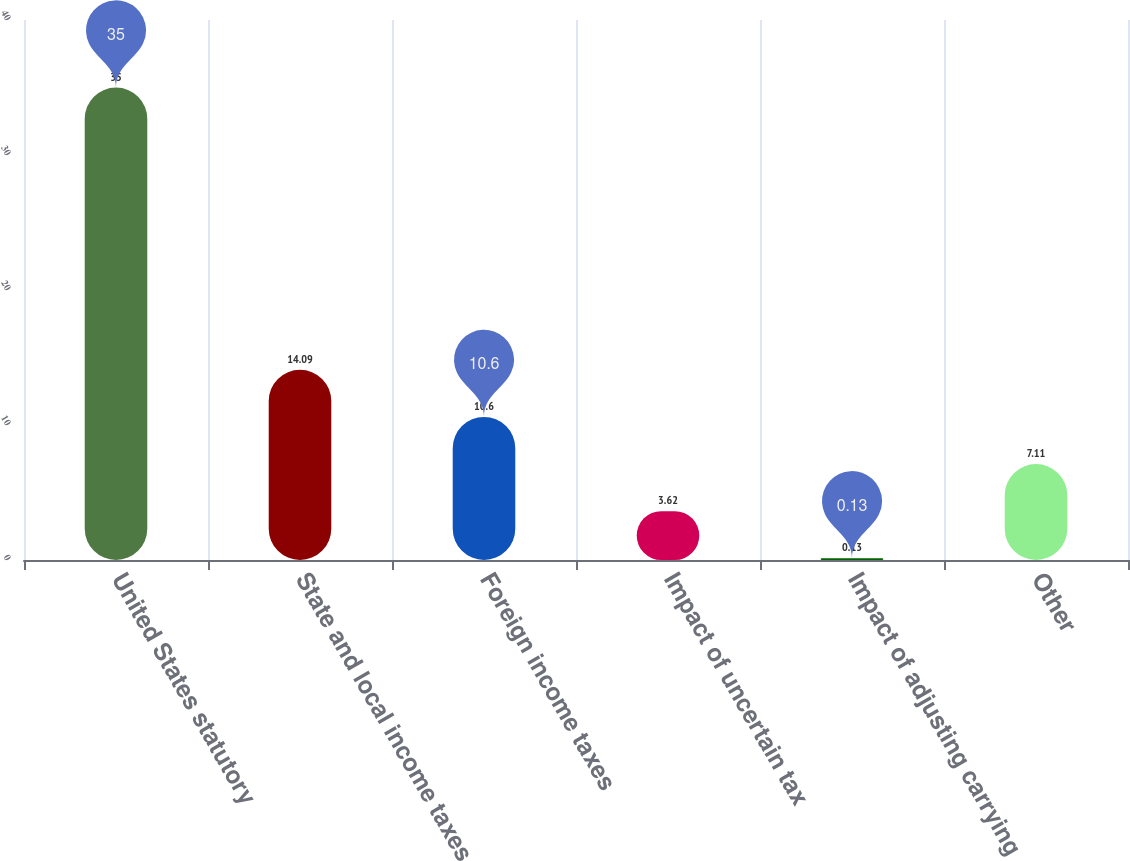Convert chart. <chart><loc_0><loc_0><loc_500><loc_500><bar_chart><fcel>United States statutory<fcel>State and local income taxes<fcel>Foreign income taxes<fcel>Impact of uncertain tax<fcel>Impact of adjusting carrying<fcel>Other<nl><fcel>35<fcel>14.09<fcel>10.6<fcel>3.62<fcel>0.13<fcel>7.11<nl></chart> 